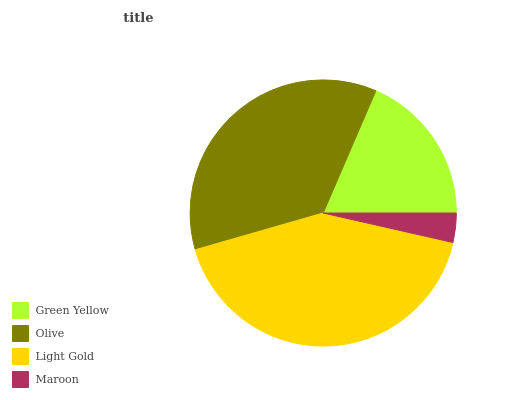Is Maroon the minimum?
Answer yes or no. Yes. Is Light Gold the maximum?
Answer yes or no. Yes. Is Olive the minimum?
Answer yes or no. No. Is Olive the maximum?
Answer yes or no. No. Is Olive greater than Green Yellow?
Answer yes or no. Yes. Is Green Yellow less than Olive?
Answer yes or no. Yes. Is Green Yellow greater than Olive?
Answer yes or no. No. Is Olive less than Green Yellow?
Answer yes or no. No. Is Olive the high median?
Answer yes or no. Yes. Is Green Yellow the low median?
Answer yes or no. Yes. Is Maroon the high median?
Answer yes or no. No. Is Light Gold the low median?
Answer yes or no. No. 